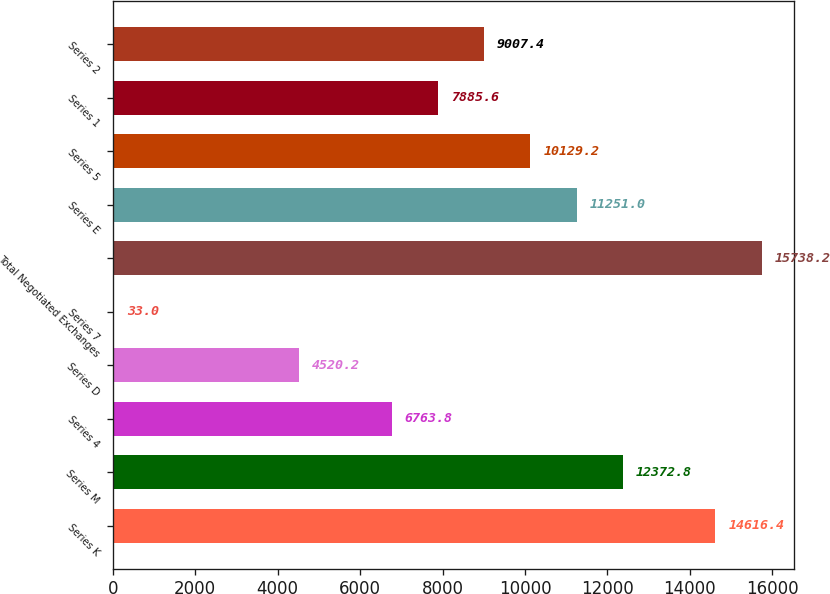Convert chart to OTSL. <chart><loc_0><loc_0><loc_500><loc_500><bar_chart><fcel>Series K<fcel>Series M<fcel>Series 4<fcel>Series D<fcel>Series 7<fcel>Total Negotiated Exchanges<fcel>Series E<fcel>Series 5<fcel>Series 1<fcel>Series 2<nl><fcel>14616.4<fcel>12372.8<fcel>6763.8<fcel>4520.2<fcel>33<fcel>15738.2<fcel>11251<fcel>10129.2<fcel>7885.6<fcel>9007.4<nl></chart> 